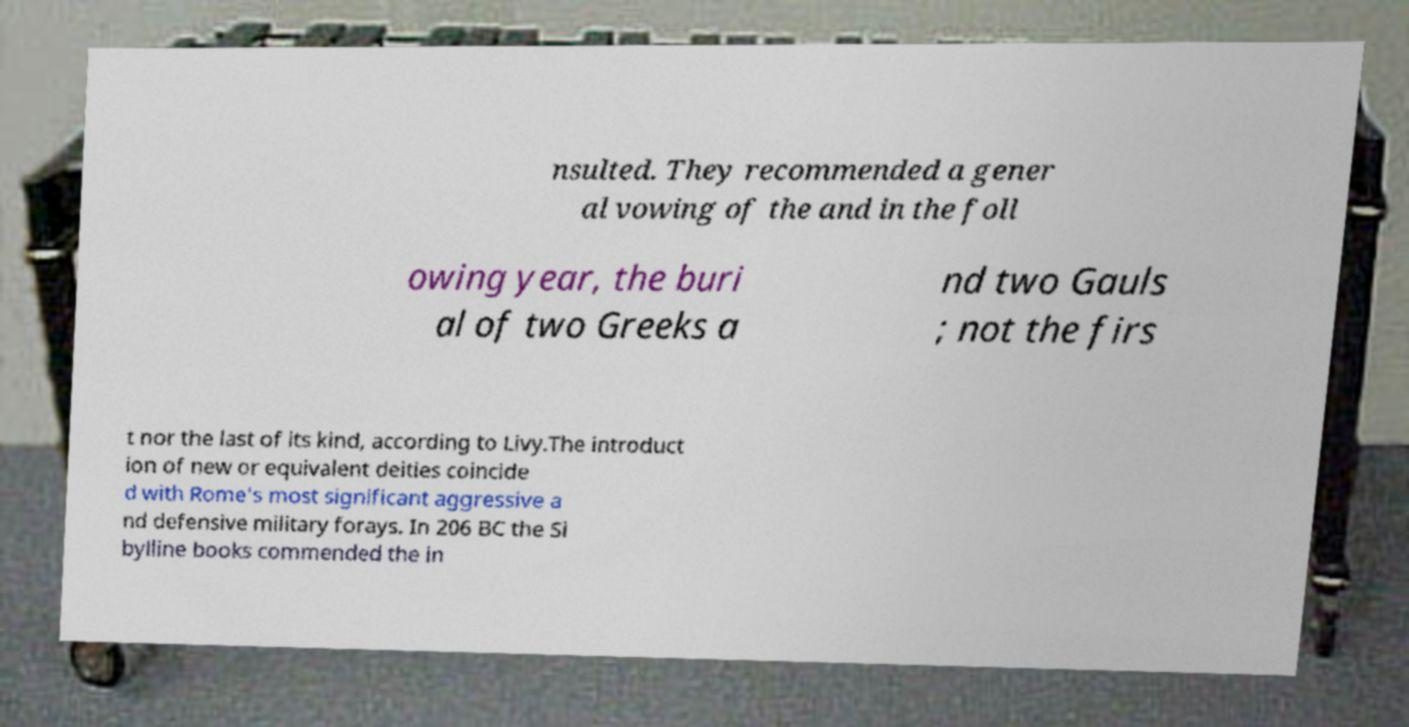Can you read and provide the text displayed in the image?This photo seems to have some interesting text. Can you extract and type it out for me? nsulted. They recommended a gener al vowing of the and in the foll owing year, the buri al of two Greeks a nd two Gauls ; not the firs t nor the last of its kind, according to Livy.The introduct ion of new or equivalent deities coincide d with Rome's most significant aggressive a nd defensive military forays. In 206 BC the Si bylline books commended the in 